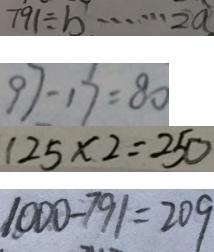Convert formula to latex. <formula><loc_0><loc_0><loc_500><loc_500>7 9 1 \div b \cdots 2 a 
 9 7 - 1 7 = 8 0 
 1 2 5 \times 2 = 2 5 0 
 1 0 0 0 - 7 9 1 = 2 0 9</formula> 